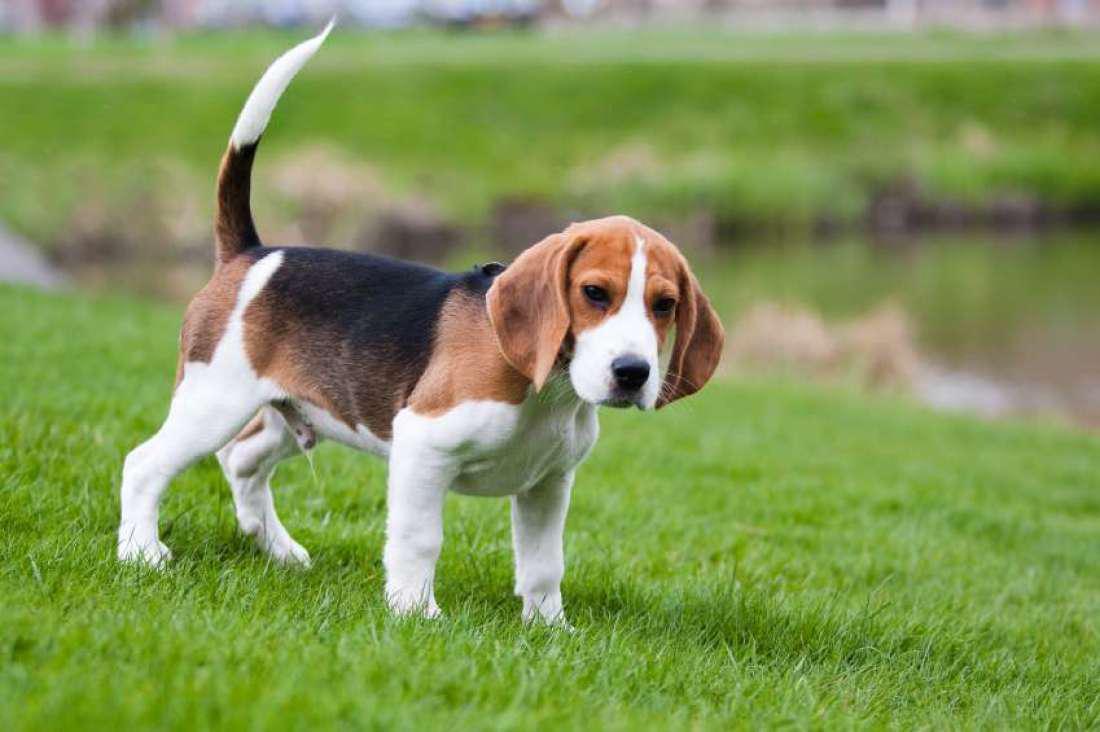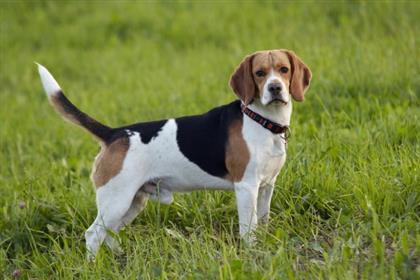The first image is the image on the left, the second image is the image on the right. Examine the images to the left and right. Is the description "The right image contains at least two dogs." accurate? Answer yes or no. No. The first image is the image on the left, the second image is the image on the right. Analyze the images presented: Is the assertion "There are more dogs in the image on the right than on the left." valid? Answer yes or no. No. 